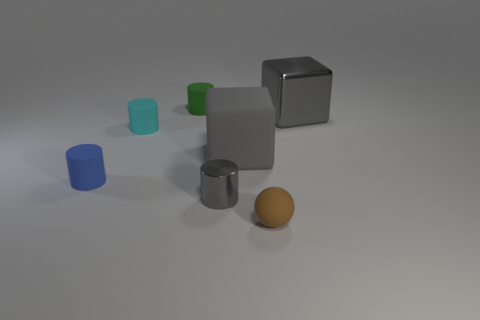Can you describe the shapes and colors of the objects in the image? Certainly! In the image, there is a variety of objects featuring different shapes and colors. There are two cubes, one is a large gray metallic cube, and the other appears smaller and is blue. There are two cylinders, one is small and green, and the other, slightly larger, is a metallic silver. Additionally, there's a small aqua-blue cylinder and a spherical object in a muted orange color. 